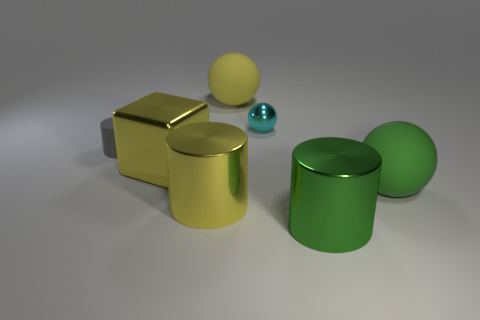Subtract all metallic cylinders. How many cylinders are left? 1 Add 1 big cyan shiny objects. How many objects exist? 8 Subtract all yellow cylinders. How many cylinders are left? 2 Subtract all blue balls. How many green cylinders are left? 1 Add 3 big red rubber cubes. How many big red rubber cubes exist? 3 Subtract 1 gray cylinders. How many objects are left? 6 Subtract all cylinders. How many objects are left? 4 Subtract 1 cylinders. How many cylinders are left? 2 Subtract all cyan spheres. Subtract all red cubes. How many spheres are left? 2 Subtract all tiny brown objects. Subtract all rubber cylinders. How many objects are left? 6 